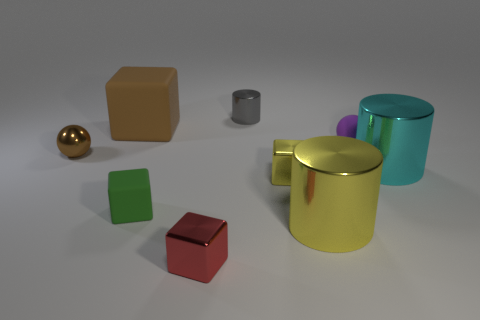There is a purple matte thing; are there any things right of it?
Give a very brief answer. Yes. What is the color of the matte object right of the red object that is on the left side of the yellow shiny object that is behind the tiny green matte cube?
Give a very brief answer. Purple. What number of small shiny things are behind the large yellow cylinder and in front of the big cyan metallic cylinder?
Provide a short and direct response. 1. What number of cubes are either cyan objects or brown rubber things?
Make the answer very short. 1. Are any cyan rubber things visible?
Your answer should be very brief. No. What number of other things are made of the same material as the cyan cylinder?
Your answer should be very brief. 5. What is the material of the brown sphere that is the same size as the gray metallic cylinder?
Keep it short and to the point. Metal. Does the matte thing that is to the right of the tiny yellow cube have the same shape as the green rubber thing?
Offer a very short reply. No. Does the big rubber block have the same color as the shiny sphere?
Make the answer very short. Yes. What number of things are tiny purple matte objects that are behind the big cyan metallic cylinder or tiny cubes?
Provide a short and direct response. 4. 